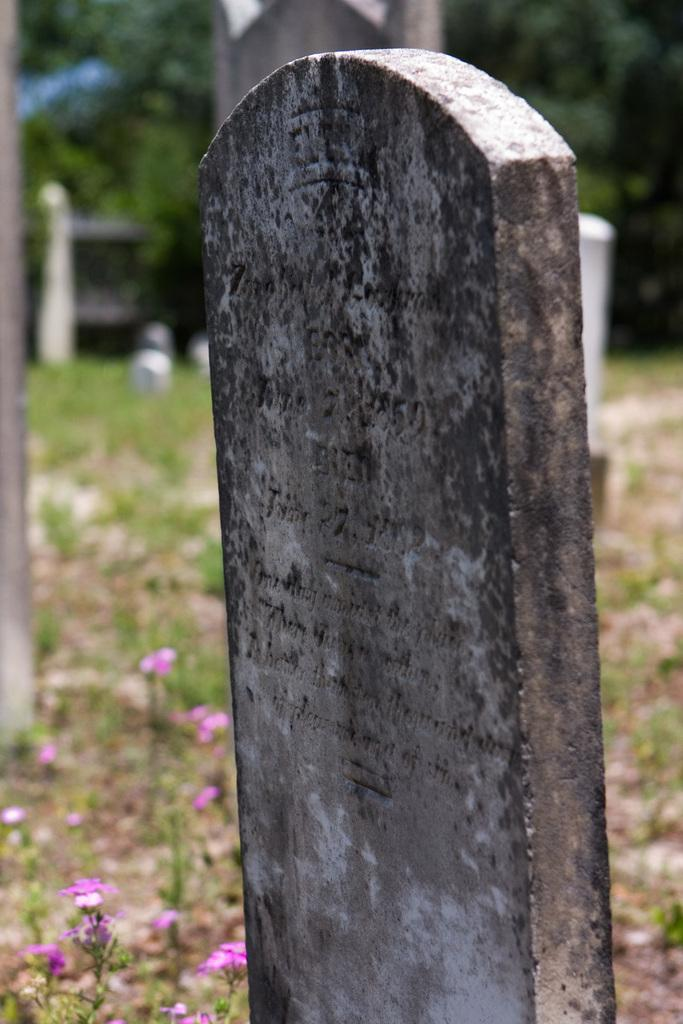What type of structures can be seen in the image? There are gravestones in the image. What type of vegetation is present in the image? There are trees and plants with flowers in the image. Where is the seat located in the image? There is no seat present in the image. What force is causing the flowers to bloom in the image? The image does not provide information about the force causing the flowers to bloom; it only shows the flowers as they are. 